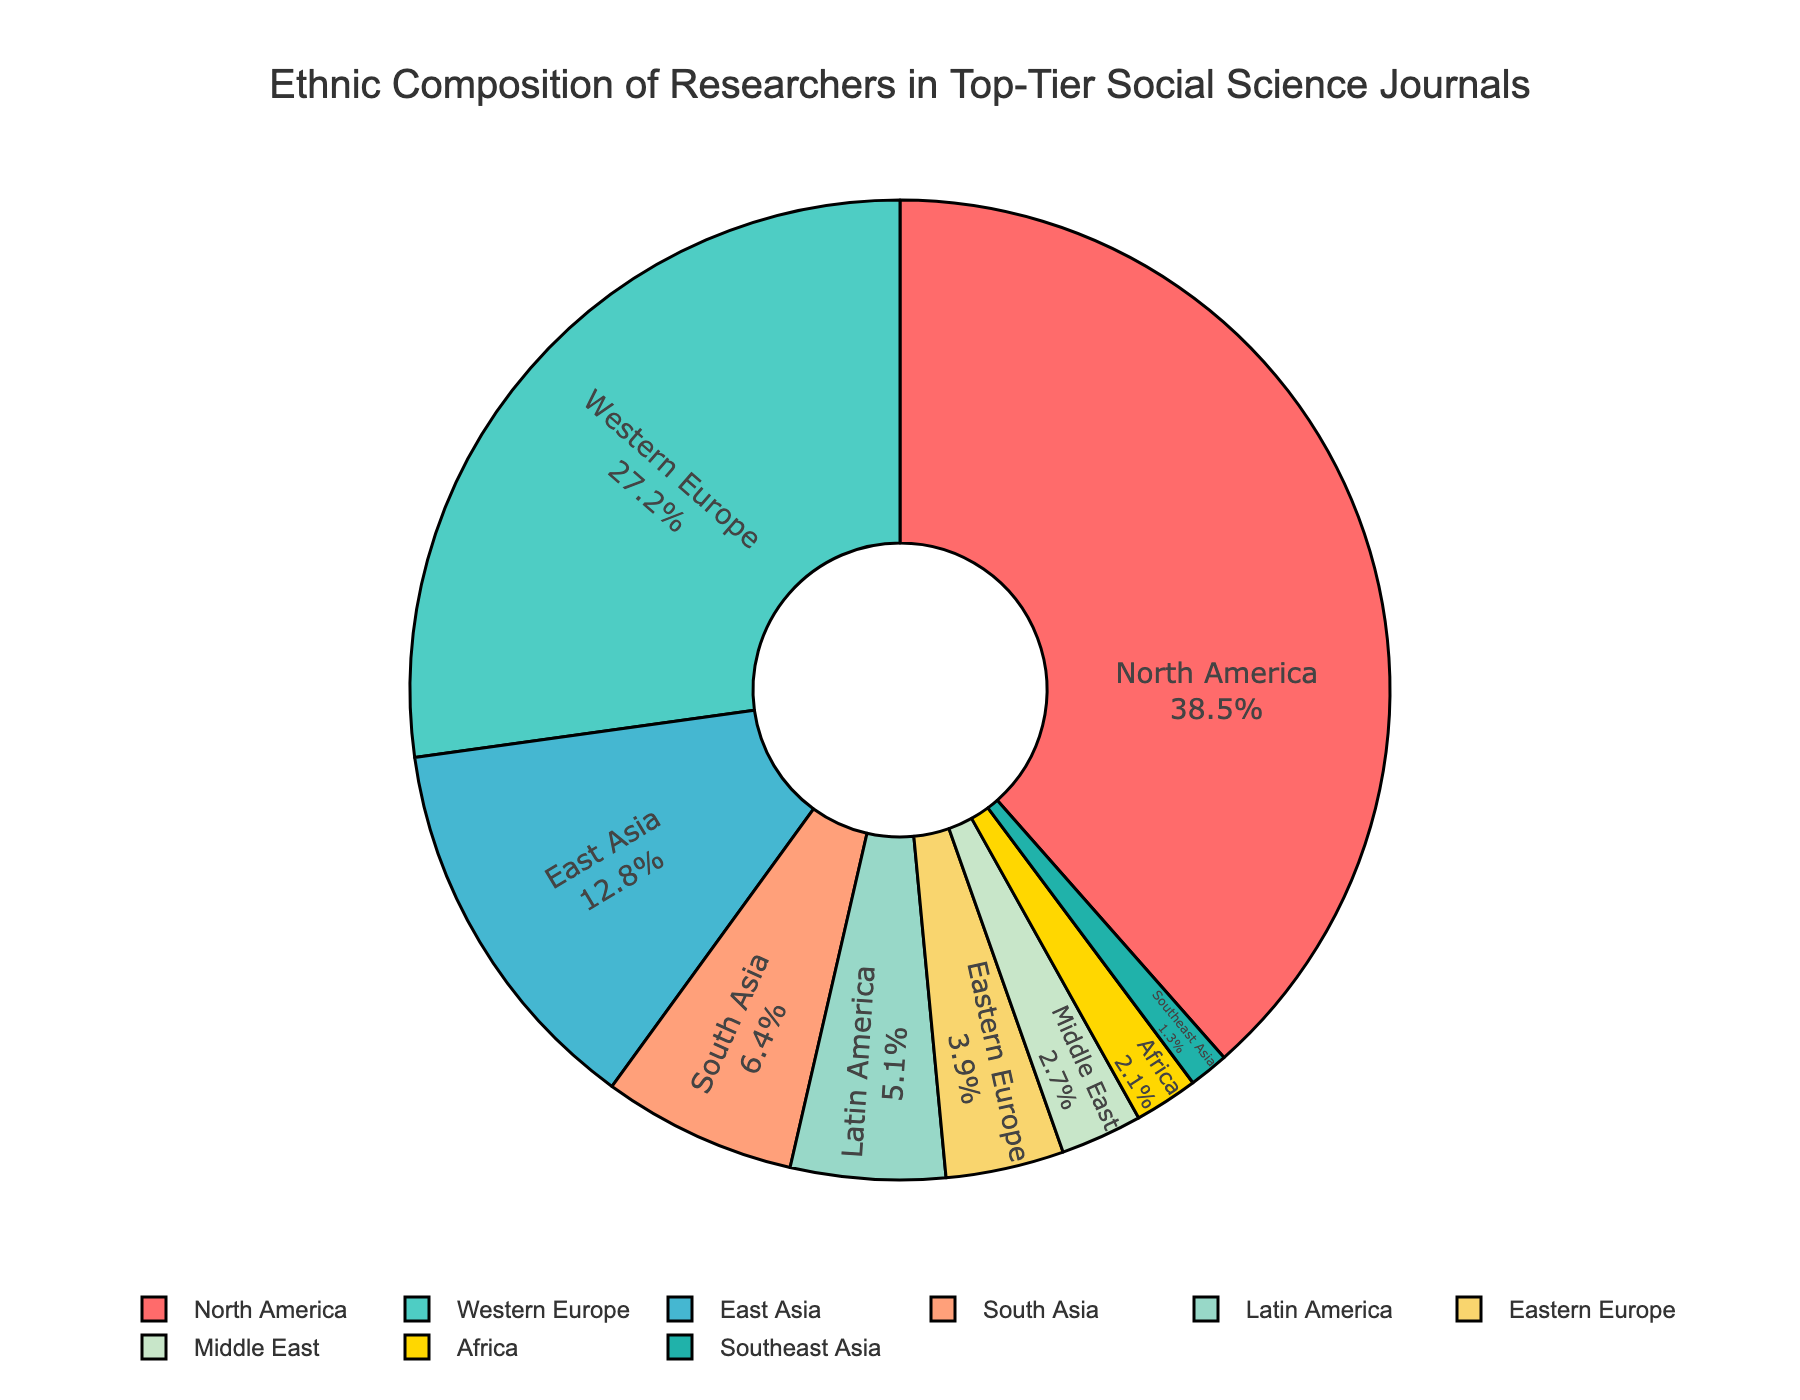What is the combined percentage of researchers from North America and Western Europe? North America has 38.5%, and Western Europe has 27.2%. Adding these together, 38.5 + 27.2 = 65.7%.
Answer: 65.7% Which region has a higher percentage of researchers, East Asia or South Asia? East Asia has 12.8%, while South Asia has 6.4%. Since 12.8 is greater than 6.4, East Asia has a higher percentage.
Answer: East Asia How much more is the percentage of researchers from Latin America compared to Africa? Latin America has 5.1%, while Africa has 2.1%. Subtraction gives 5.1 - 2.1 = 3.0%.
Answer: 3.0% Which regions fall below the 5% mark in terms of researcher representation? East Asia (12.8%), South Asia (6.4%), and Latin America (5.1%) are above 5%. The regions below 5% are Eastern Europe (3.9%), Middle East (2.7%), Africa (2.1%), and Southeast Asia (1.3%).
Answer: Eastern Europe, Middle East, Africa, Southeast Asia What percentage of researchers come from regions not located in either the Americas or Europe? Non-Americas/Non-Europeans: East Asia (12.8%), South Asia (6.4%), Middle East (2.7%), Africa (2.1%), Southeast Asia (1.3%). Adding these, 12.8 + 6.4 + 2.7 + 2.1 + 1.3 = 25.3%.
Answer: 25.3% If the percentage of researchers from North America increased by 5%, what would be the new total percentage for North America and Western Europe combined? North America's original percentage is 38.5%, increased by 5% to 43.5%. Western Europe remains 27.2%. Adding these, 43.5 + 27.2 = 70.7%.
Answer: 70.7% What is the color representing the region with the smallest percentage of researchers? The smallest percentage is Southeast Asia with 1.3%. The color representing it is green.
Answer: Green How does the percentage of researchers from Eastern Europe compare with that from the Middle East? Eastern Europe has 3.9%, while the Middle East has 2.7%. Comparing, 3.9% is greater than 2.7%.
Answer: Eastern Europe has a higher percentage What is the difference in the percentage of researchers between the region with the highest and the region with the lowest representation? The highest is North America with 38.5%, and the lowest is Southeast Asia with 1.3%. The difference is 38.5 - 1.3 = 37.2%.
Answer: 37.2% What fraction of the total percentage is represented by South Asia? South Asia has 6.4%. Out of a total of 100%, the fraction is 6.4/100, which simplifies to 0.064 or 6.4%.
Answer: 0.064 or 6.4% 